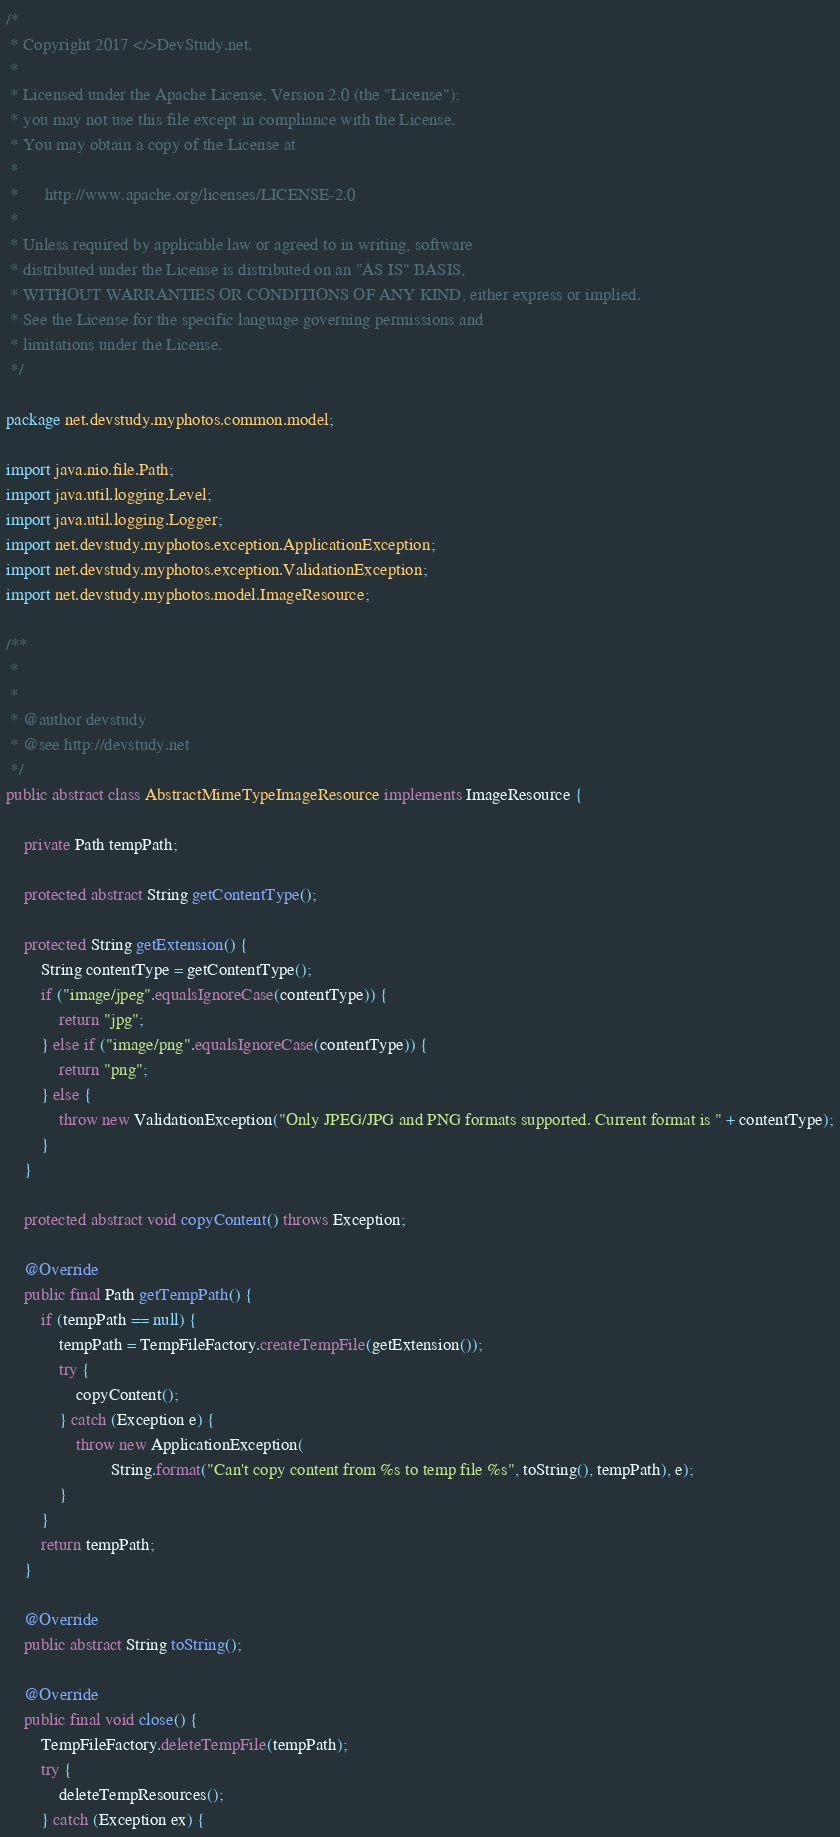<code> <loc_0><loc_0><loc_500><loc_500><_Java_>/*
 * Copyright 2017 </>DevStudy.net.
 *
 * Licensed under the Apache License, Version 2.0 (the "License");
 * you may not use this file except in compliance with the License.
 * You may obtain a copy of the License at
 *
 *      http://www.apache.org/licenses/LICENSE-2.0
 *
 * Unless required by applicable law or agreed to in writing, software
 * distributed under the License is distributed on an "AS IS" BASIS,
 * WITHOUT WARRANTIES OR CONDITIONS OF ANY KIND, either express or implied.
 * See the License for the specific language governing permissions and
 * limitations under the License.
 */

package net.devstudy.myphotos.common.model;

import java.nio.file.Path;
import java.util.logging.Level;
import java.util.logging.Logger;
import net.devstudy.myphotos.exception.ApplicationException;
import net.devstudy.myphotos.exception.ValidationException;
import net.devstudy.myphotos.model.ImageResource;

/**
 *
 *
 * @author devstudy
 * @see http://devstudy.net
 */
public abstract class AbstractMimeTypeImageResource implements ImageResource {
    
    private Path tempPath;
    
    protected abstract String getContentType();

    protected String getExtension() {
        String contentType = getContentType();
        if ("image/jpeg".equalsIgnoreCase(contentType)) {
            return "jpg";
        } else if ("image/png".equalsIgnoreCase(contentType)) {
            return "png";
        } else {
            throw new ValidationException("Only JPEG/JPG and PNG formats supported. Current format is " + contentType);
        }
    }

    protected abstract void copyContent() throws Exception;

    @Override
    public final Path getTempPath() {
        if (tempPath == null) {
            tempPath = TempFileFactory.createTempFile(getExtension());
            try {
                copyContent();
            } catch (Exception e) {
                throw new ApplicationException(
                        String.format("Can't copy content from %s to temp file %s", toString(), tempPath), e);
            }
        }
        return tempPath;
    }
    
    @Override
    public abstract String toString();

    @Override
    public final void close() {
        TempFileFactory.deleteTempFile(tempPath);
        try {
            deleteTempResources();
        } catch (Exception ex) {</code> 